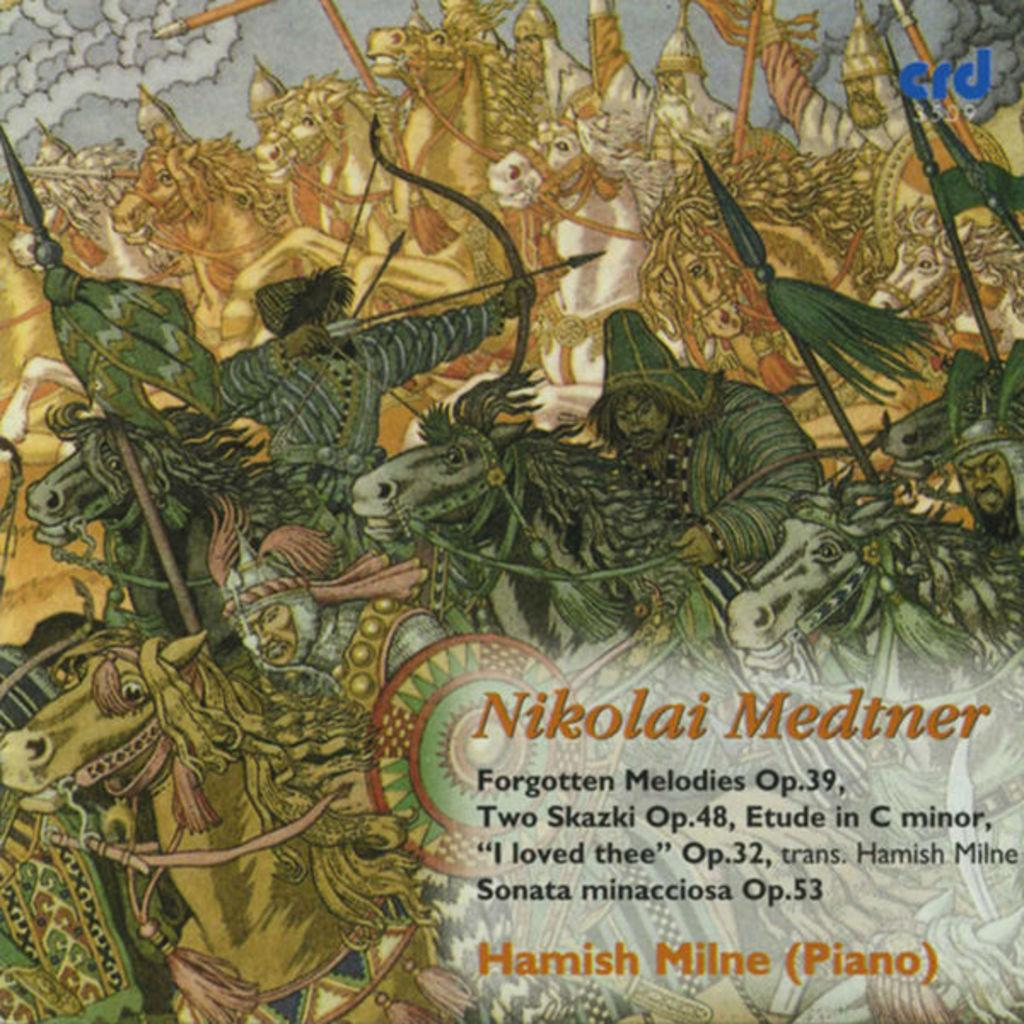Who or what can be seen in the image? There are persons and horses in the image. What objects are associated with the persons or horses? There are bows and arrows in the image. Is there any text present in the image? Yes, there is text in the bottom right corner of the image. How many legs can be seen on the farm in the image? There is no farm present in the image, so it is not possible to determine the number of legs. 